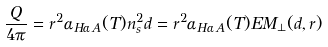<formula> <loc_0><loc_0><loc_500><loc_500>\frac { Q } { 4 \pi } = r ^ { 2 } \alpha _ { H \alpha \, A } ( T ) n _ { s } ^ { 2 } d = r ^ { 2 } \alpha _ { H \alpha \, A } ( T ) E M _ { \perp } ( d , r )</formula> 